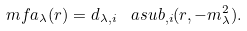Convert formula to latex. <formula><loc_0><loc_0><loc_500><loc_500>\ m f a _ { \lambda } ( r ) = d _ { \lambda , i } \, \ a s u b _ { , i } ( r , - m _ { \lambda } ^ { 2 } ) .</formula> 